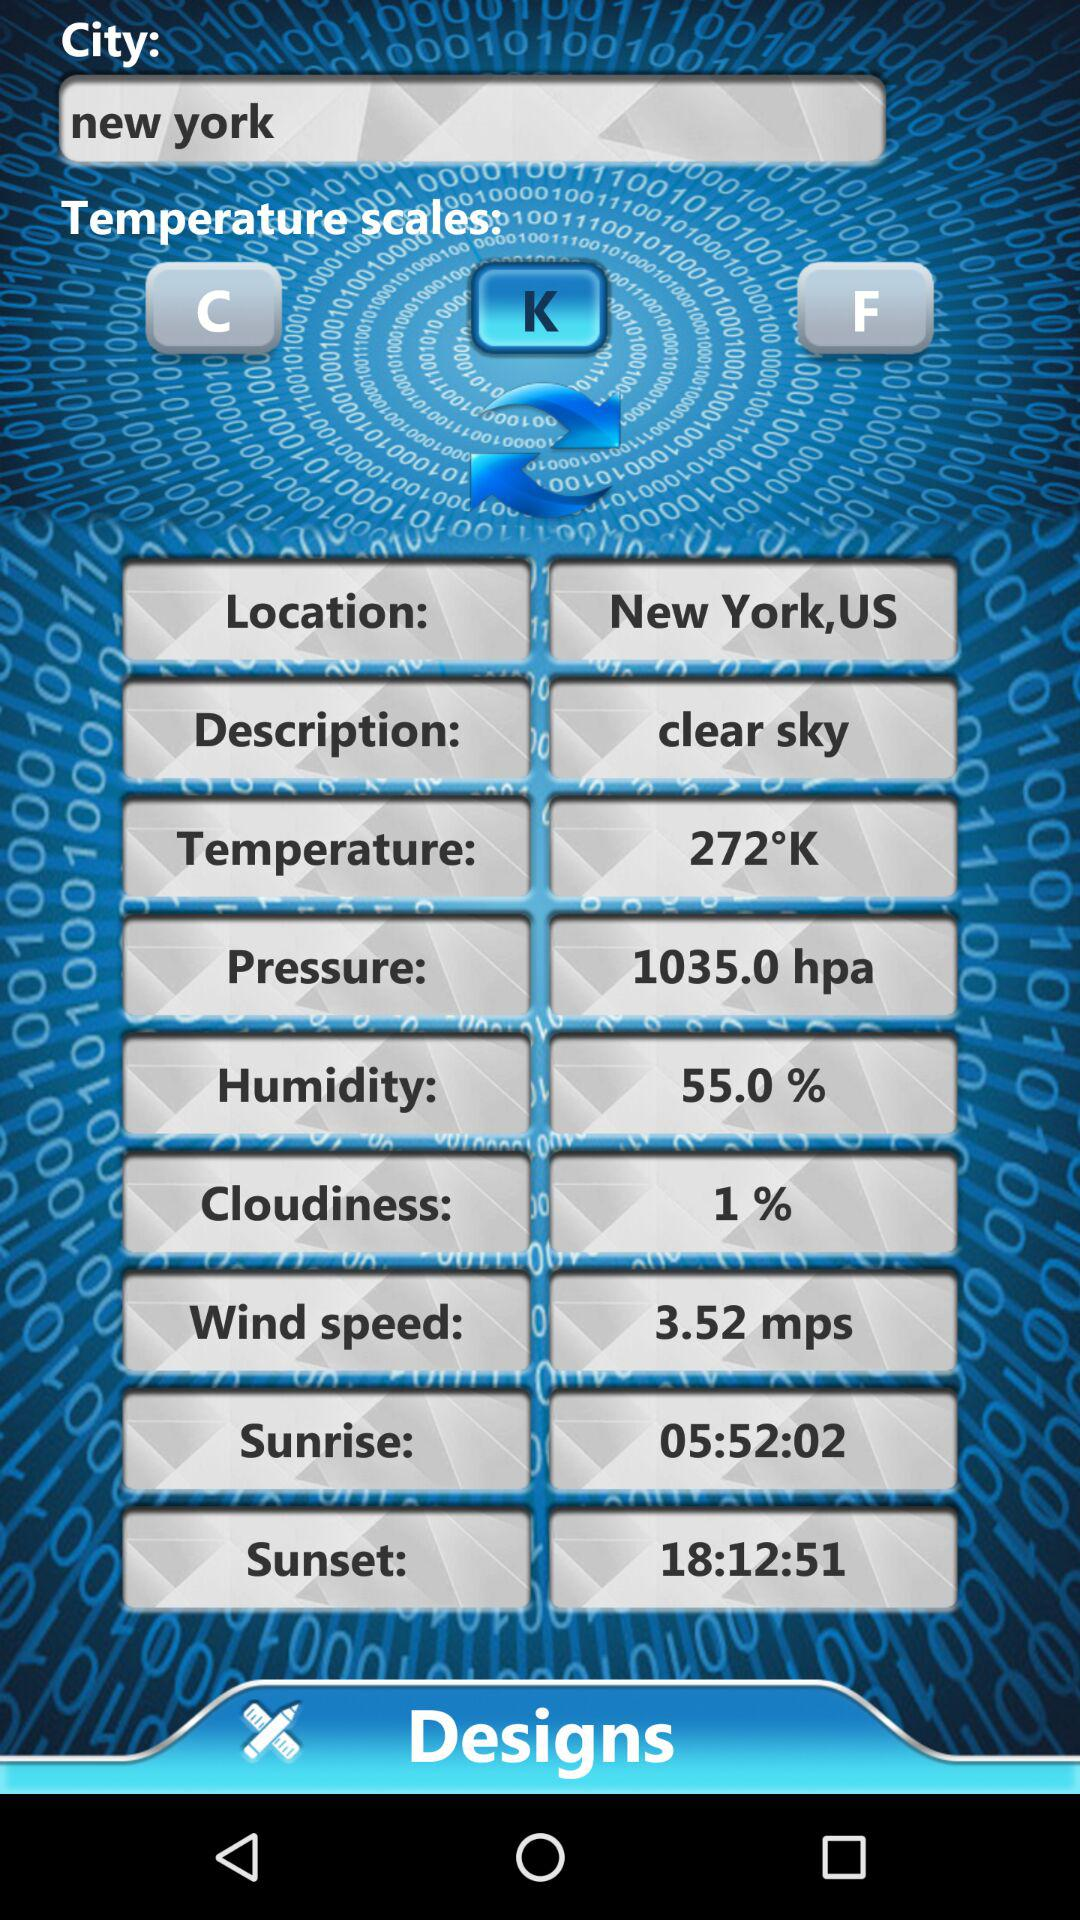What is the selected city? The selected city is New York. 